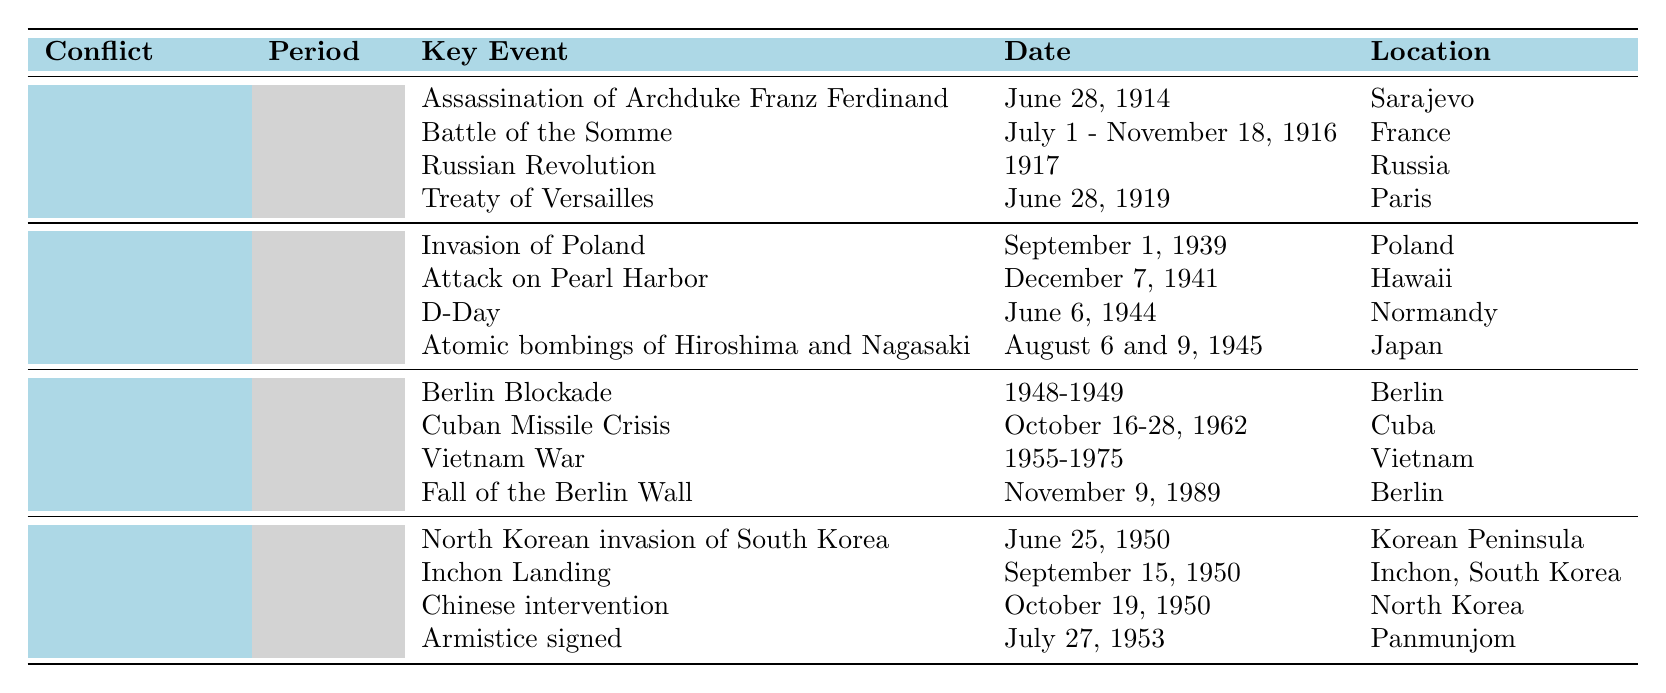What is the period of World War I? The table lists World War I under the "Conflict" column, and the corresponding period is provided in that row, which states "1914-1918".
Answer: 1914-1918 Which event occurred on December 7, 1941, during World War II? By referring to the World War II section of the table, we can see that the event listed for December 7, 1941, is the "Attack on Pearl Harbor".
Answer: Attack on Pearl Harbor How many key events are listed for the Cold War? Looking at the Cold War section, there are four events listed: Berlin Blockade, Cuban Missile Crisis, Vietnam War, and Fall of the Berlin Wall. We simply count them.
Answer: 4 Was the Treaty of Versailles signed before or after the Russian Revolution? The table indicates that the Treaty of Versailles was signed on June 28, 1919, and the Russian Revolution occurred in 1917. Since 1919 is after 1917, the answer is that the treaty was signed after the revolution.
Answer: After What was the last event listed for the Korean War, and when did it occur? In the Korean War section, the last event is "Armistice signed", and it occurred on July 27, 1953, as noted in the respective row.
Answer: Armistice signed; July 27, 1953 Which conflict experienced a major event labeled "D-Day," and what is the date of that event? The table shows that "D-Day" is an event in World War II, occurring on June 6, 1944, according to its respective row.
Answer: World War II; June 6, 1944 Compare the duration of World War I and World War II. How many more years did World War II last compared to World War I? World War I lasted from 1914 to 1918, totalling 4 years. World War II lasted from 1939 to 1945, totalling 6 years. The difference is calculated as 6 - 4 = 2 years.
Answer: 2 years During which conflict did the Cuban Missile Crisis take place, and what were its dates? The Cuban Missile Crisis is found in the Cold War section of the table, with the dates provided as October 16-28, 1962. Therefore, it can be concluded that this event took place during the Cold War.
Answer: Cold War; October 16-28, 1962 Which country was involved in the "Inchon Landing" event during the Korean War? The table indicates that "Inchon Landing" occurred in Inchon, South Korea, making South Korea the country involved in this event.
Answer: South Korea Identify the event that directly preceded the Fall of the Berlin Wall and provide its date. By examining the key events under the Cold War, we find that the event directly preceding the Fall of the Berlin Wall is the Vietnam War, which lasted from 1955 to 1975. It's a broader time frame, but no event is listed immediately beforehand in this context.
Answer: Vietnam War; 1955-1975 